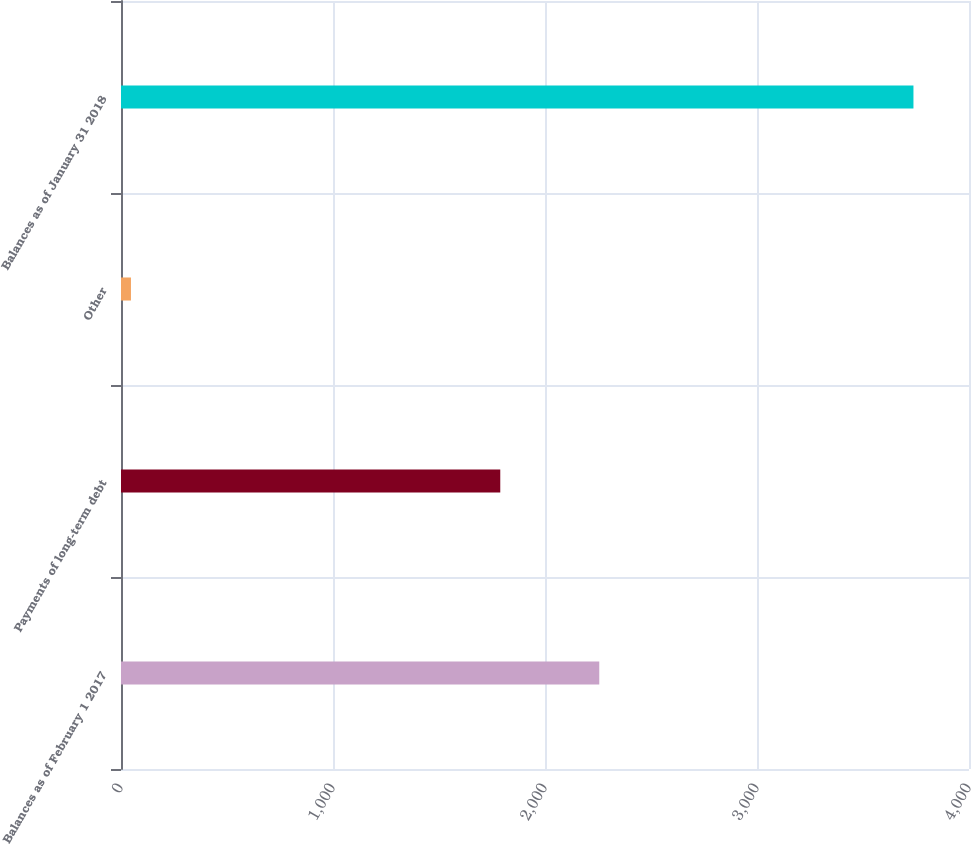<chart> <loc_0><loc_0><loc_500><loc_500><bar_chart><fcel>Balances as of February 1 2017<fcel>Payments of long-term debt<fcel>Other<fcel>Balances as of January 31 2018<nl><fcel>2256<fcel>1789<fcel>47<fcel>3738<nl></chart> 